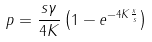<formula> <loc_0><loc_0><loc_500><loc_500>p = \frac { s \gamma } { 4 K } \left ( 1 - e ^ { - 4 K \frac { x } { s } } \right )</formula> 